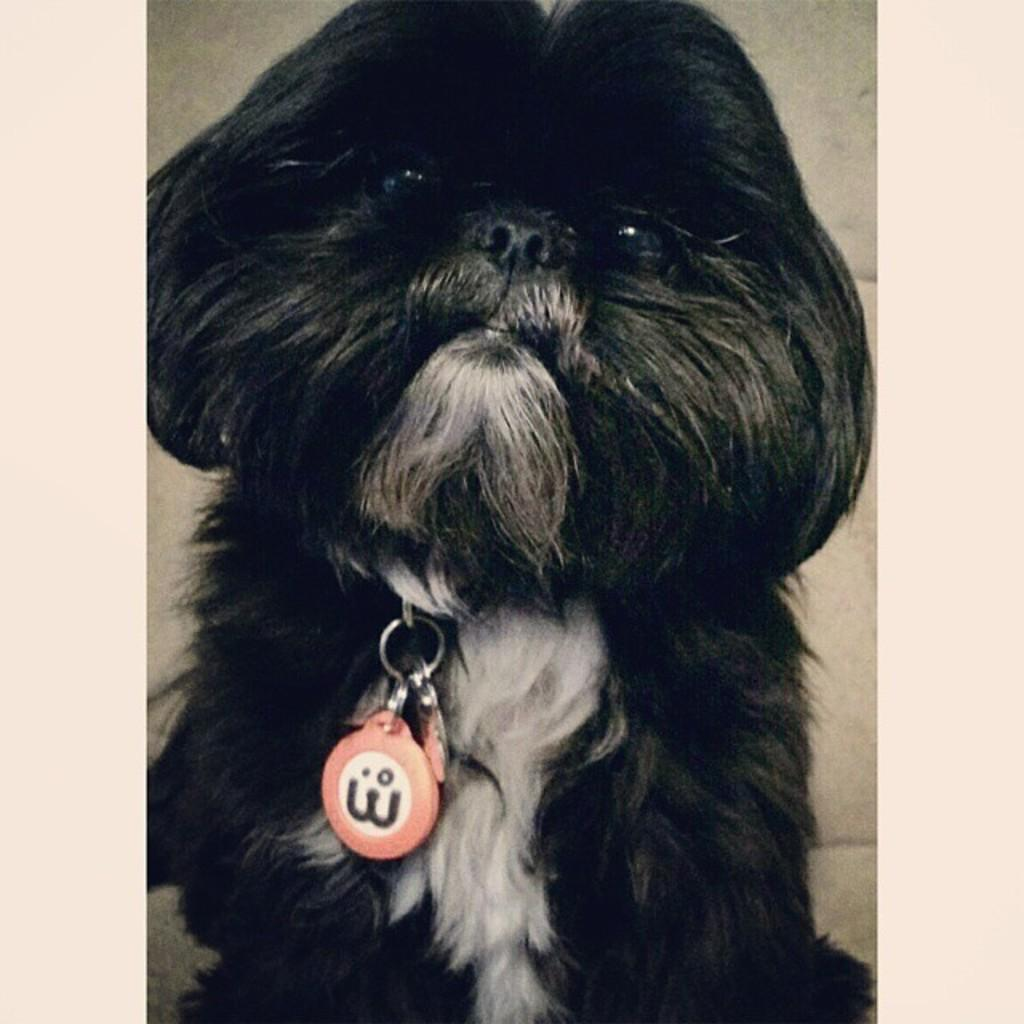What type of animal is in the image? There is a dog in the image. Can you describe the dog's appearance? The dog is black and cream in color. What is around the dog's neck? The dog has a badge around its neck. What colors are on the badge? The badge is pink and white in color. What is the background color in the image? The background of the image is cream colored. Is the dog playing with steam in the image? There is no steam present in the image. 